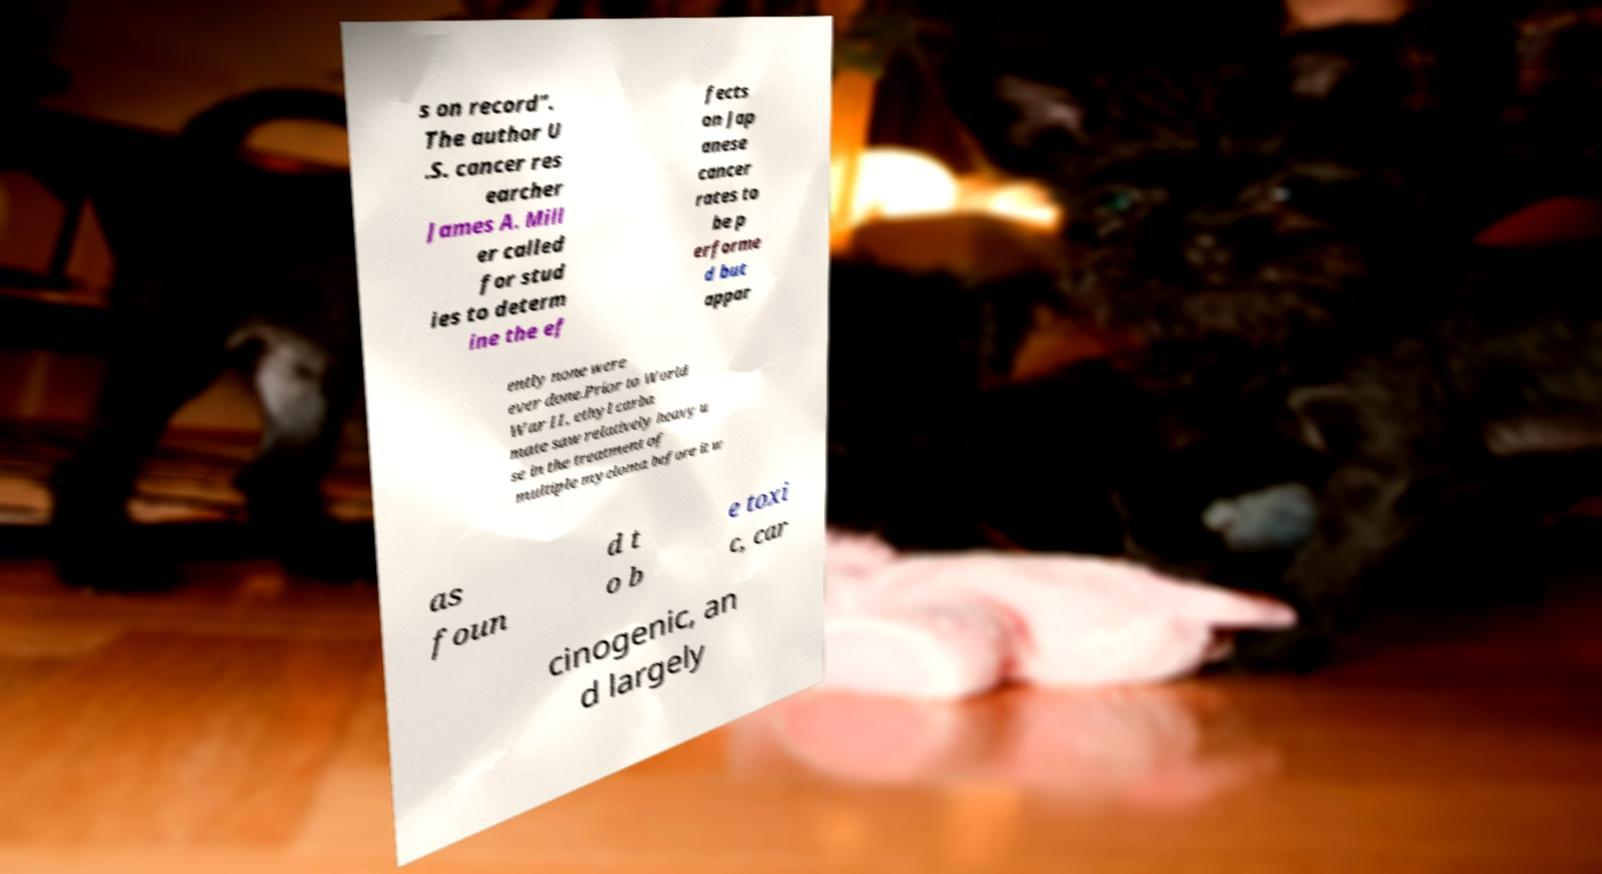Can you accurately transcribe the text from the provided image for me? s on record". The author U .S. cancer res earcher James A. Mill er called for stud ies to determ ine the ef fects on Jap anese cancer rates to be p erforme d but appar ently none were ever done.Prior to World War II, ethyl carba mate saw relatively heavy u se in the treatment of multiple myeloma before it w as foun d t o b e toxi c, car cinogenic, an d largely 